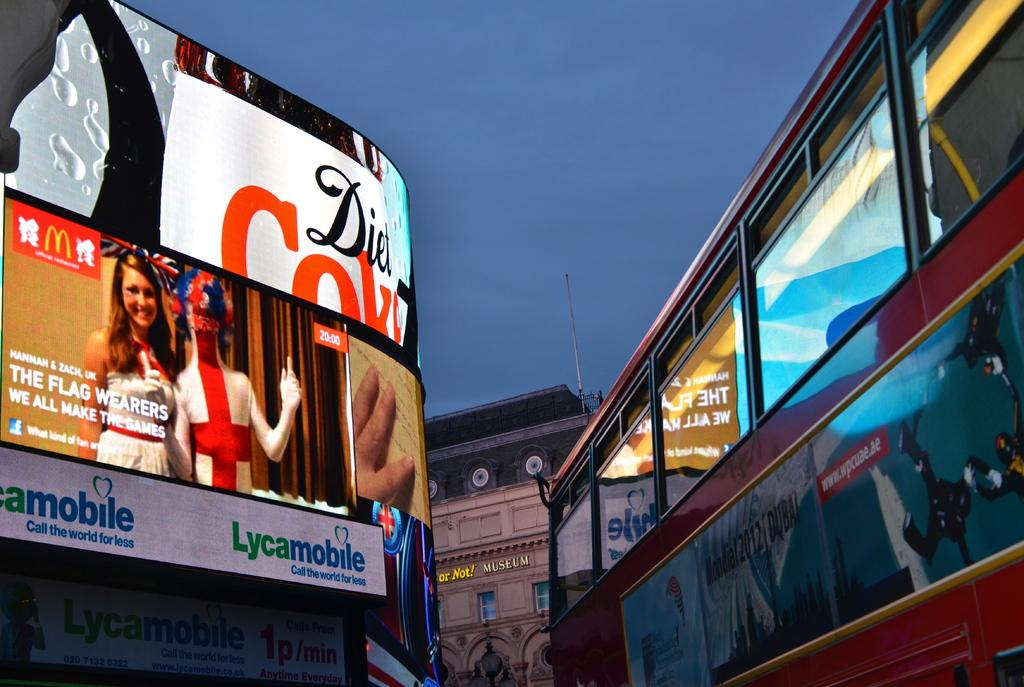<image>
Create a compact narrative representing the image presented. Video billboards on display that read Diet Coke and Lycamobile. 